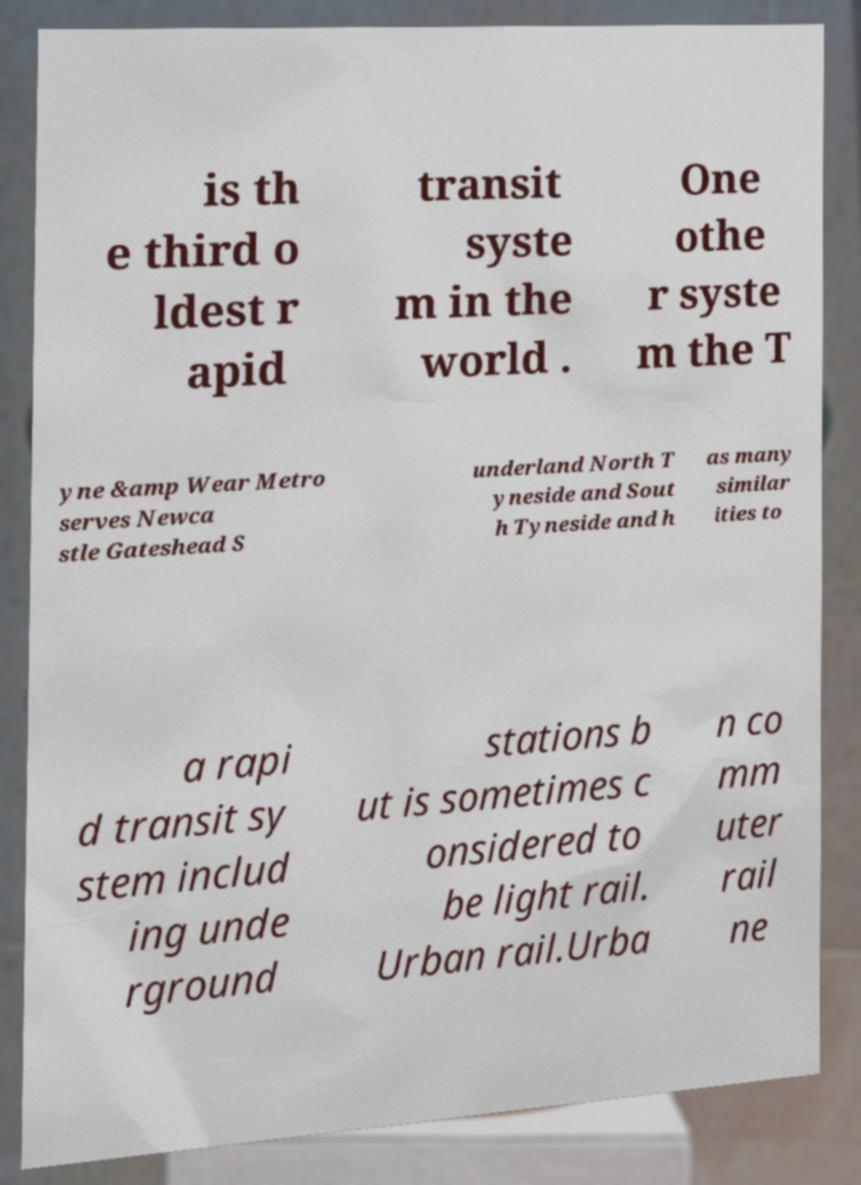There's text embedded in this image that I need extracted. Can you transcribe it verbatim? is th e third o ldest r apid transit syste m in the world . One othe r syste m the T yne &amp Wear Metro serves Newca stle Gateshead S underland North T yneside and Sout h Tyneside and h as many similar ities to a rapi d transit sy stem includ ing unde rground stations b ut is sometimes c onsidered to be light rail. Urban rail.Urba n co mm uter rail ne 